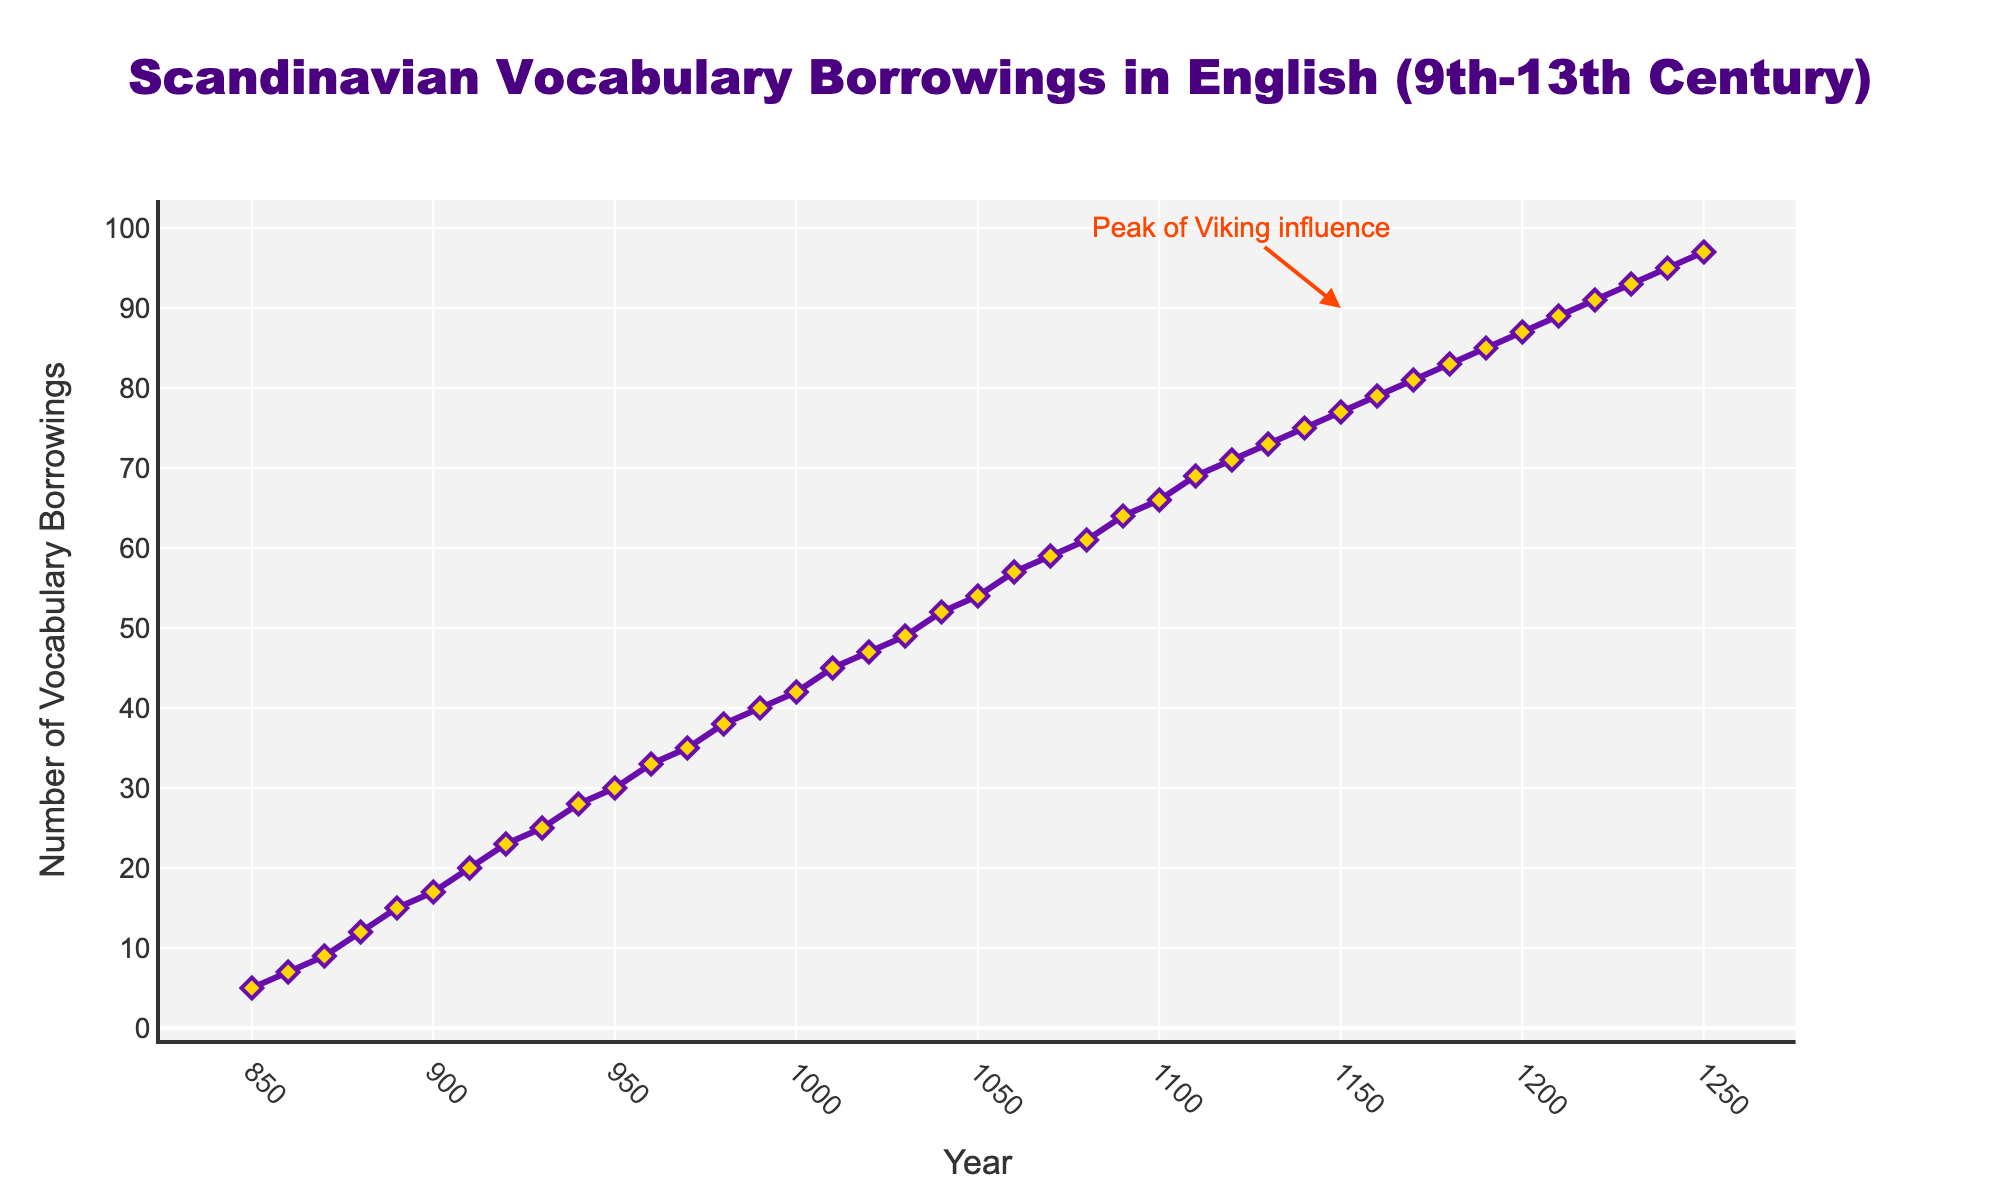what is the title of the figure? The title can be found at the top part of the figure, typically in a larger font and centered. The title in this case is "Scandinavian Vocabulary Borrowings in English (9th-13th Century)".
Answer: Scandinavian Vocabulary Borrowings in English (9th-13th Century) how many vocabulary borrowings were there in the year 900? Locate the point corresponding to the year 900 on the x-axis and look at its corresponding value on the y-axis. In this case, the number of vocabulary borrowings for the year 900 is 17.
Answer: 17 when did the number of vocabulary borrowings reach 50? Draw a horizontal line at the y-value of 50 and find the intersection point on the x-axis. The vocabulary borrowings reached 50 around the year 1040.
Answer: 1040 how did the number of vocabulary borrowings change from the year 1050 to 1100? Find the y-values for the years 1050 and 1100. The number of borrowings increased from 54 in 1050 to 66 in 1100, indicating an increase of 12.
Answer: Increased by 12 what is the most significant observation indicated by the annotation? The annotation text in the figure mentions "Peak of Viking influence" and is located around the year 1150. It suggests that the highest impact of Viking influence on vocabulary borrowing is around this period.
Answer: Peak of Viking influence around 1150 which decade had the greatest increase in vocabulary borrowings and by how much? To find the greatest increase, compare the difference in borrowings between consecutive decades. The decade between 890 and 900 saw an increase from 15 to 17 borrowings, which is an increase of 2. Similarly, the increase for other decades can be obtained. The decade with the greatest increase is from 1040 to 1050, which saw a rise from 52 to 54 borrowings. The largest increase occurred from 1160 to 1170, with borrowings rising from 79 to 81, a difference of 2.
Answer: 1160 to 1170, increase of 2 how many data points are plotted in the figure? Each point on the graph corresponds to a specific year and the number of vocabulary borrowings in that year. By counting the distinct points on the plot, there are 41 data points representing the years from 850 to 1250 every 10 years.
Answer: 41 what trend can be observed in the number of vocabulary borrowings from 900 to 1250? Observe the overall direction of the line from 900 to 1250. The line shows a generally increasing trend, indicating that the number of vocabulary borrowings steadily increased over this period.
Answer: Increasing trend compare the number of vocabulary borrowings in the 10th century to those in the 12th century Summarize the number of borrowings for the 10th century (years 900-999) versus the 12th century (years 1200-1299). For the 10th century, the values range approximately from 17 to 42. For the 12th century, the values range approximately from 83 to 89.
Answer: More borrowings in the 12th century 